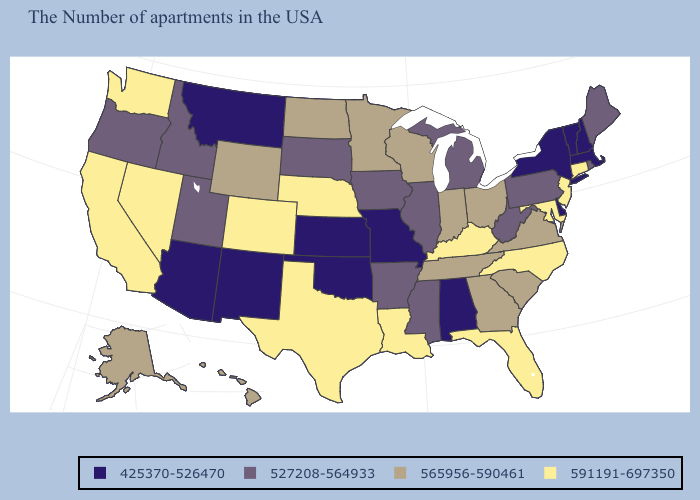What is the highest value in the MidWest ?
Short answer required. 591191-697350. How many symbols are there in the legend?
Be succinct. 4. Which states have the highest value in the USA?
Short answer required. Connecticut, New Jersey, Maryland, North Carolina, Florida, Kentucky, Louisiana, Nebraska, Texas, Colorado, Nevada, California, Washington. Does Maine have the same value as Illinois?
Answer briefly. Yes. Does Wisconsin have the highest value in the MidWest?
Write a very short answer. No. Which states have the lowest value in the MidWest?
Concise answer only. Missouri, Kansas. Among the states that border South Dakota , which have the highest value?
Give a very brief answer. Nebraska. Name the states that have a value in the range 425370-526470?
Write a very short answer. Massachusetts, New Hampshire, Vermont, New York, Delaware, Alabama, Missouri, Kansas, Oklahoma, New Mexico, Montana, Arizona. How many symbols are there in the legend?
Answer briefly. 4. Name the states that have a value in the range 425370-526470?
Give a very brief answer. Massachusetts, New Hampshire, Vermont, New York, Delaware, Alabama, Missouri, Kansas, Oklahoma, New Mexico, Montana, Arizona. Does Nevada have a lower value than North Dakota?
Write a very short answer. No. What is the value of Oregon?
Concise answer only. 527208-564933. Name the states that have a value in the range 527208-564933?
Write a very short answer. Maine, Rhode Island, Pennsylvania, West Virginia, Michigan, Illinois, Mississippi, Arkansas, Iowa, South Dakota, Utah, Idaho, Oregon. Name the states that have a value in the range 565956-590461?
Write a very short answer. Virginia, South Carolina, Ohio, Georgia, Indiana, Tennessee, Wisconsin, Minnesota, North Dakota, Wyoming, Alaska, Hawaii. 